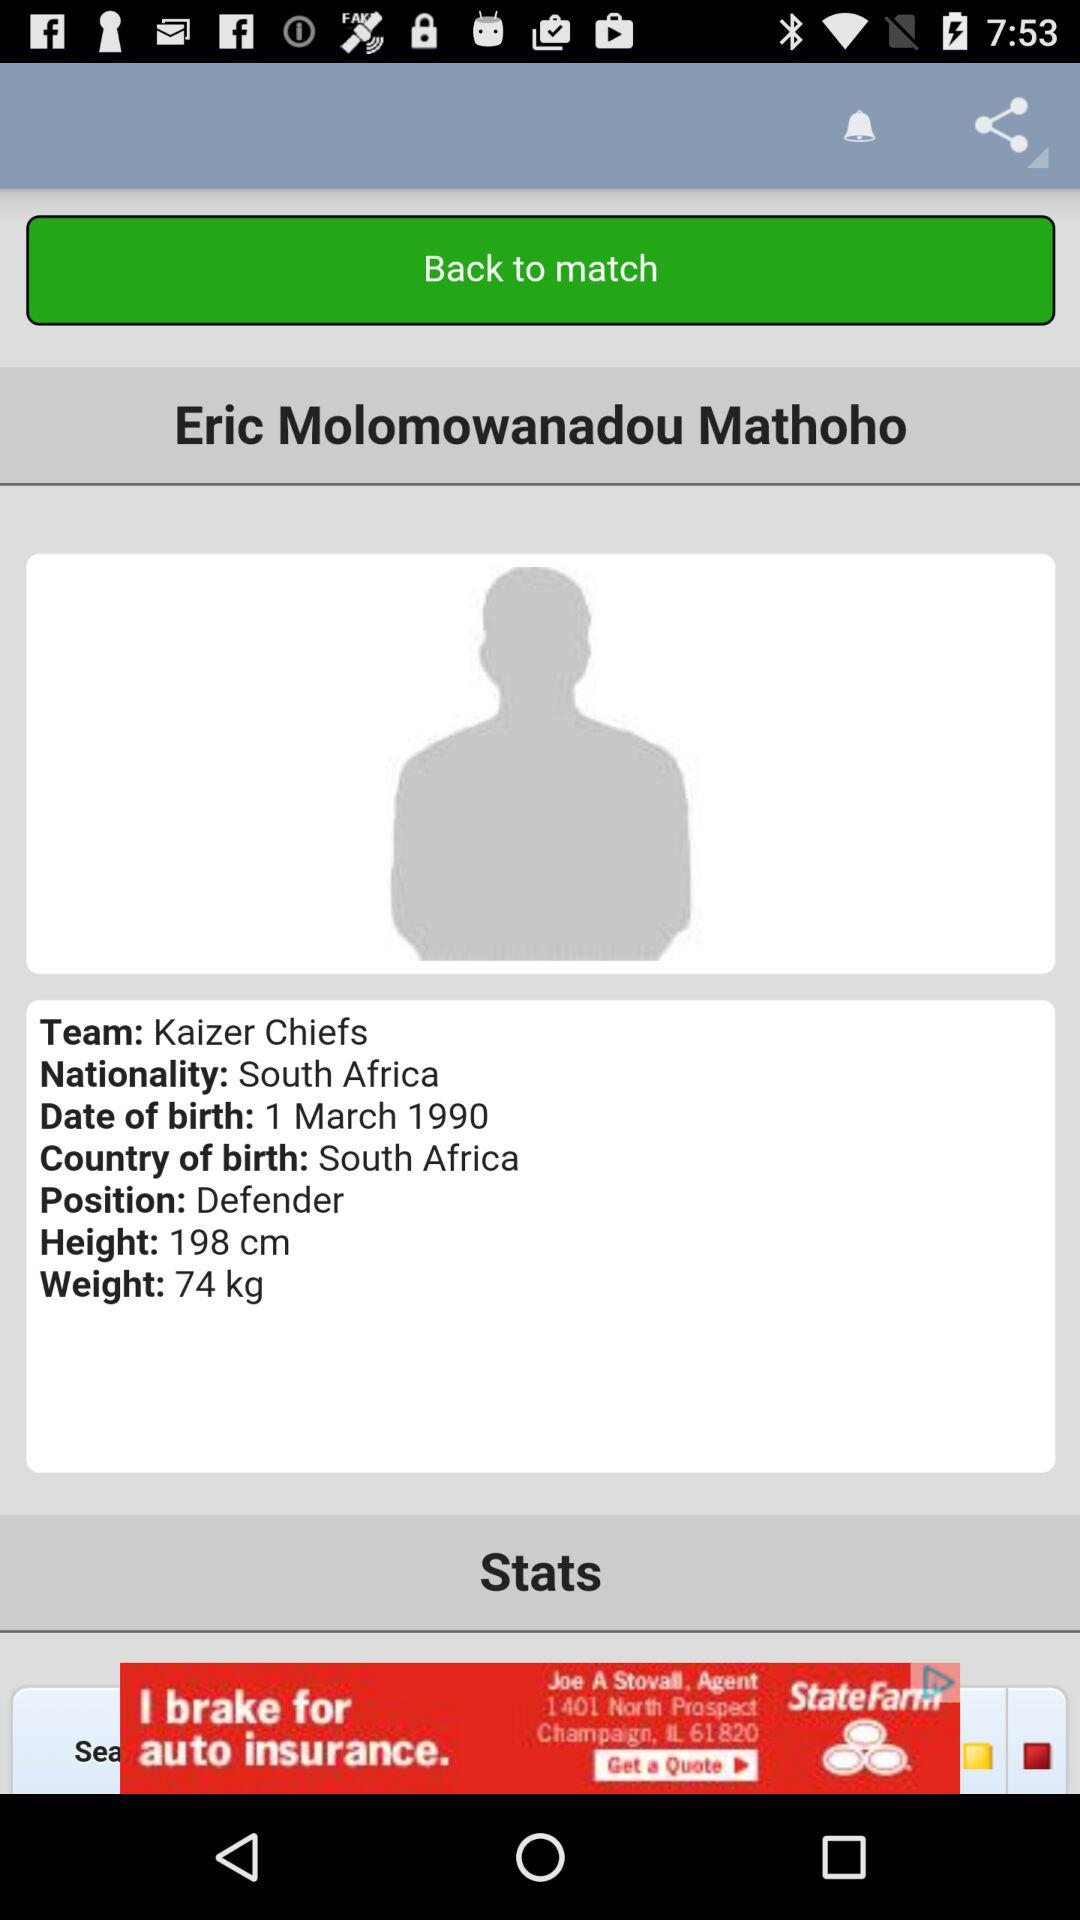What is the name of the player? The name of the player is Eric Molomowanadou Mathoho. 